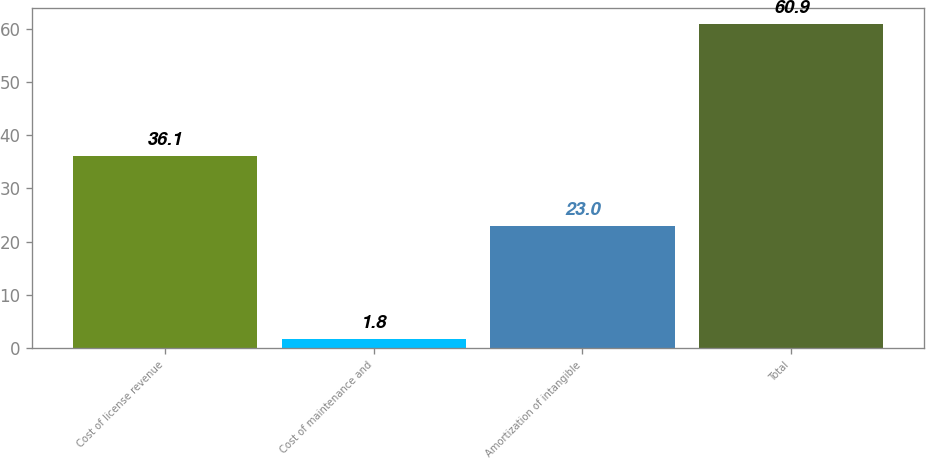Convert chart. <chart><loc_0><loc_0><loc_500><loc_500><bar_chart><fcel>Cost of license revenue<fcel>Cost of maintenance and<fcel>Amortization of intangible<fcel>Total<nl><fcel>36.1<fcel>1.8<fcel>23<fcel>60.9<nl></chart> 